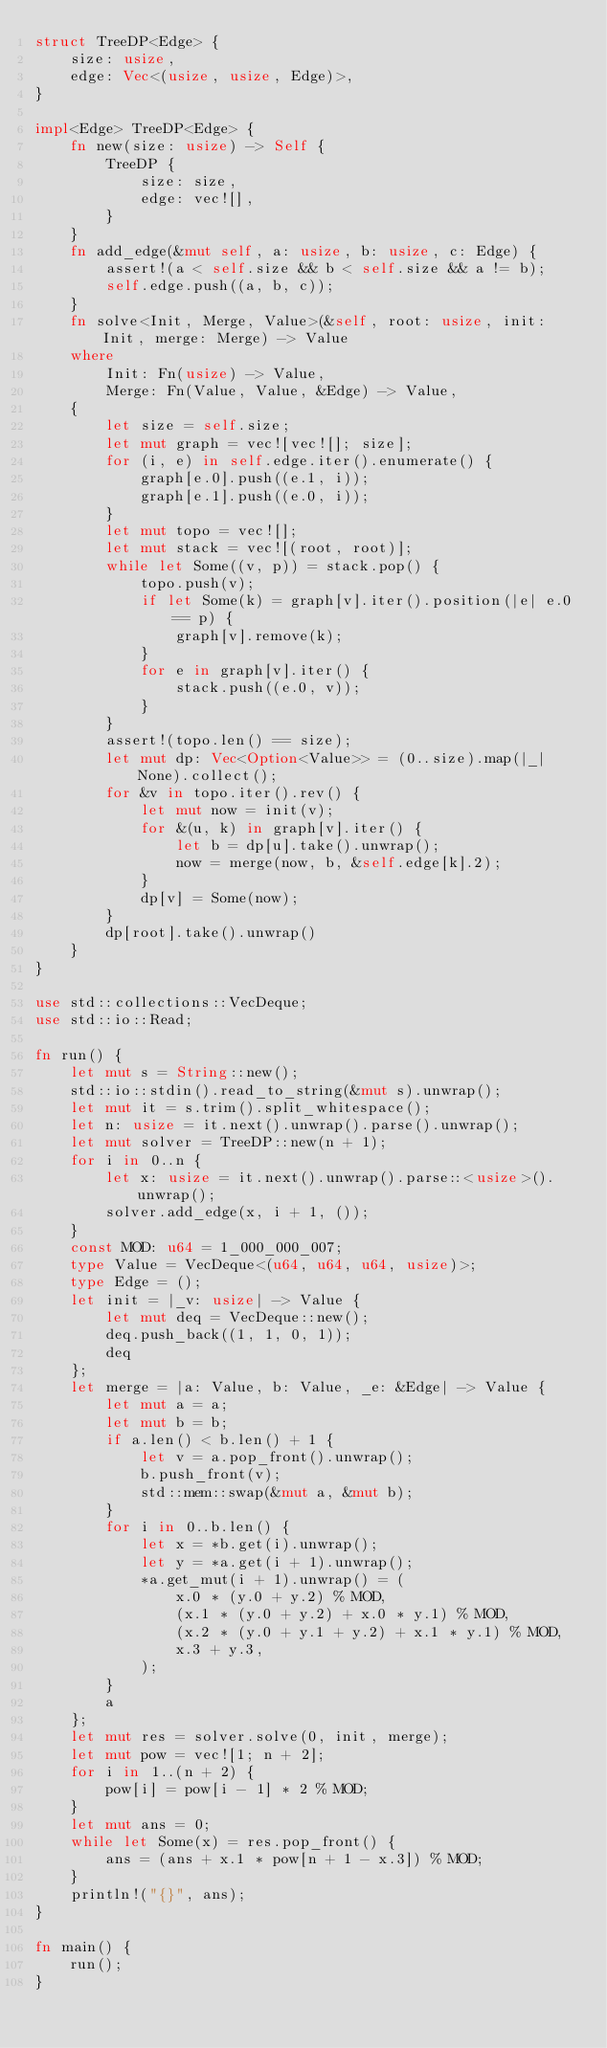<code> <loc_0><loc_0><loc_500><loc_500><_Rust_>struct TreeDP<Edge> {
    size: usize,
    edge: Vec<(usize, usize, Edge)>,
}

impl<Edge> TreeDP<Edge> {
    fn new(size: usize) -> Self {
        TreeDP {
            size: size,
            edge: vec![],
        }
    }
    fn add_edge(&mut self, a: usize, b: usize, c: Edge) {
        assert!(a < self.size && b < self.size && a != b);
        self.edge.push((a, b, c));
    }
    fn solve<Init, Merge, Value>(&self, root: usize, init: Init, merge: Merge) -> Value
    where
        Init: Fn(usize) -> Value,
        Merge: Fn(Value, Value, &Edge) -> Value,
    {
        let size = self.size;
        let mut graph = vec![vec![]; size];
        for (i, e) in self.edge.iter().enumerate() {
            graph[e.0].push((e.1, i));
            graph[e.1].push((e.0, i));
        }
        let mut topo = vec![];
        let mut stack = vec![(root, root)];
        while let Some((v, p)) = stack.pop() {
            topo.push(v);
            if let Some(k) = graph[v].iter().position(|e| e.0 == p) {
                graph[v].remove(k);
            }
            for e in graph[v].iter() {
                stack.push((e.0, v));
            }
        }
        assert!(topo.len() == size);
        let mut dp: Vec<Option<Value>> = (0..size).map(|_| None).collect();
        for &v in topo.iter().rev() {
            let mut now = init(v);
            for &(u, k) in graph[v].iter() {
                let b = dp[u].take().unwrap();
                now = merge(now, b, &self.edge[k].2);
            }
            dp[v] = Some(now);
        }
        dp[root].take().unwrap()
    }
}

use std::collections::VecDeque;
use std::io::Read;

fn run() {
    let mut s = String::new();
    std::io::stdin().read_to_string(&mut s).unwrap();
    let mut it = s.trim().split_whitespace();
    let n: usize = it.next().unwrap().parse().unwrap();
    let mut solver = TreeDP::new(n + 1);
    for i in 0..n {
        let x: usize = it.next().unwrap().parse::<usize>().unwrap();
        solver.add_edge(x, i + 1, ());
    }
    const MOD: u64 = 1_000_000_007;
    type Value = VecDeque<(u64, u64, u64, usize)>;
    type Edge = ();
    let init = |_v: usize| -> Value {
        let mut deq = VecDeque::new();
        deq.push_back((1, 1, 0, 1));
        deq
    };
    let merge = |a: Value, b: Value, _e: &Edge| -> Value {
        let mut a = a;
        let mut b = b;
        if a.len() < b.len() + 1 {
            let v = a.pop_front().unwrap();
            b.push_front(v);
            std::mem::swap(&mut a, &mut b);
        }
        for i in 0..b.len() {
            let x = *b.get(i).unwrap();
            let y = *a.get(i + 1).unwrap();
            *a.get_mut(i + 1).unwrap() = (
                x.0 * (y.0 + y.2) % MOD,
                (x.1 * (y.0 + y.2) + x.0 * y.1) % MOD,
                (x.2 * (y.0 + y.1 + y.2) + x.1 * y.1) % MOD,
                x.3 + y.3,
            );
        }
        a
    };
    let mut res = solver.solve(0, init, merge);
    let mut pow = vec![1; n + 2];
    for i in 1..(n + 2) {
        pow[i] = pow[i - 1] * 2 % MOD;
    }
    let mut ans = 0;
    while let Some(x) = res.pop_front() {
        ans = (ans + x.1 * pow[n + 1 - x.3]) % MOD;
    }
    println!("{}", ans);
}

fn main() {
    run();
}
</code> 